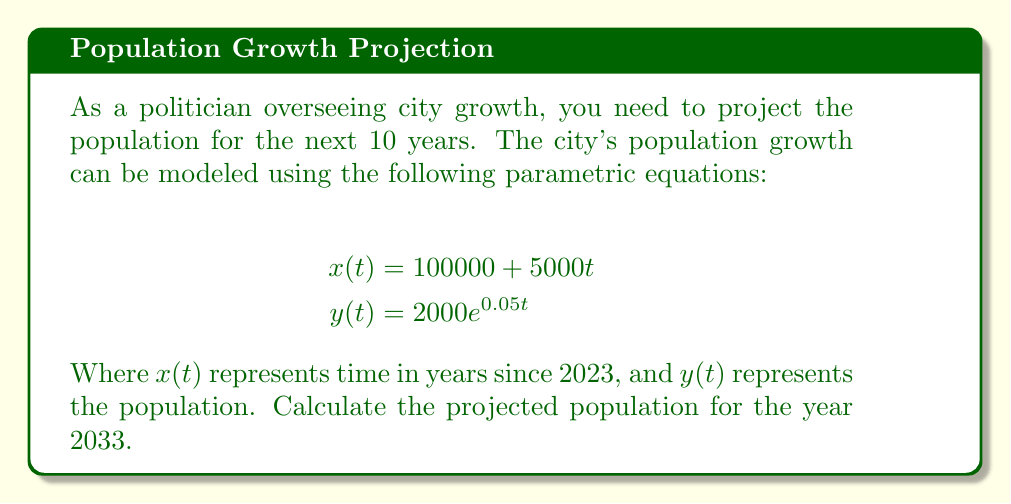What is the answer to this math problem? To solve this problem, we'll follow these steps:

1) First, we need to determine the value of $t$ for the year 2033:
   2033 is 10 years from 2023, so $t = 10$

2) Now, we substitute $t = 10$ into the equation for $y(t)$:
   $$y(10) = 2000e^{0.05(10)}$$

3) Simplify the exponent:
   $$y(10) = 2000e^{0.5}$$

4) Calculate $e^{0.5}$ (you can use a calculator for this):
   $$e^{0.5} \approx 1.6487$$

5) Multiply by 2000:
   $$y(10) = 2000 * 1.6487 \approx 3297.4$$

6) Round to the nearest whole number, as population is typically expressed in whole numbers:
   $$y(10) \approx 3297$$

Therefore, the projected population for 2033 is approximately 3,297 people.
Answer: 3,297 people 